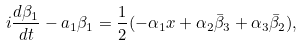Convert formula to latex. <formula><loc_0><loc_0><loc_500><loc_500>i \frac { d \beta _ { 1 } } { d t } - a _ { 1 } \beta _ { 1 } = \frac { 1 } { 2 } ( - \alpha _ { 1 } x + \alpha _ { 2 } \bar { \beta } _ { 3 } + \alpha _ { 3 } \bar { \beta } _ { 2 } ) ,</formula> 